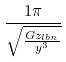<formula> <loc_0><loc_0><loc_500><loc_500>\frac { 1 \pi } { \sqrt { \frac { G z _ { l b n } } { y ^ { 3 } } } }</formula> 